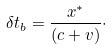<formula> <loc_0><loc_0><loc_500><loc_500>\delta t _ { b } = \frac { x ^ { * } } { ( c + v ) } \cdot</formula> 